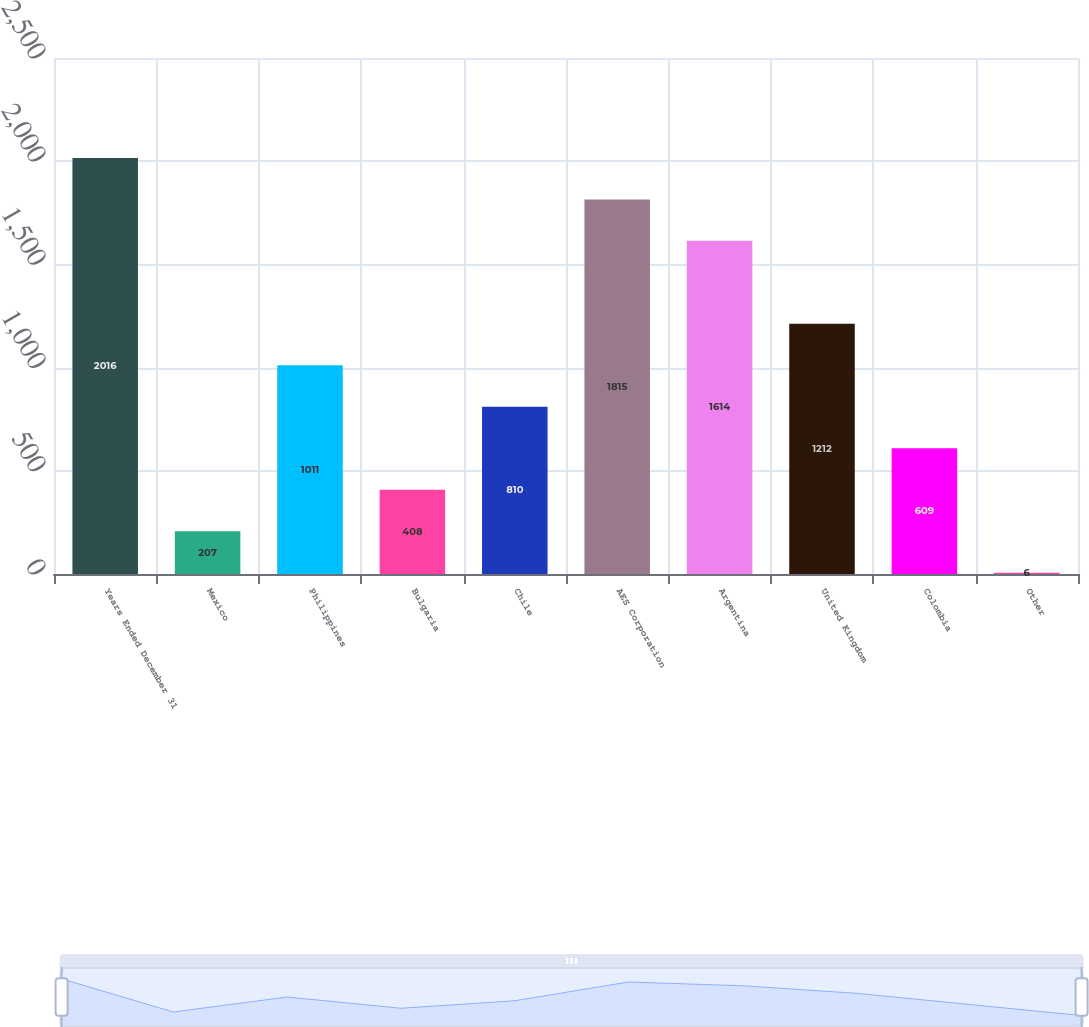<chart> <loc_0><loc_0><loc_500><loc_500><bar_chart><fcel>Years Ended December 31<fcel>Mexico<fcel>Philippines<fcel>Bulgaria<fcel>Chile<fcel>AES Corporation<fcel>Argentina<fcel>United Kingdom<fcel>Colombia<fcel>Other<nl><fcel>2016<fcel>207<fcel>1011<fcel>408<fcel>810<fcel>1815<fcel>1614<fcel>1212<fcel>609<fcel>6<nl></chart> 